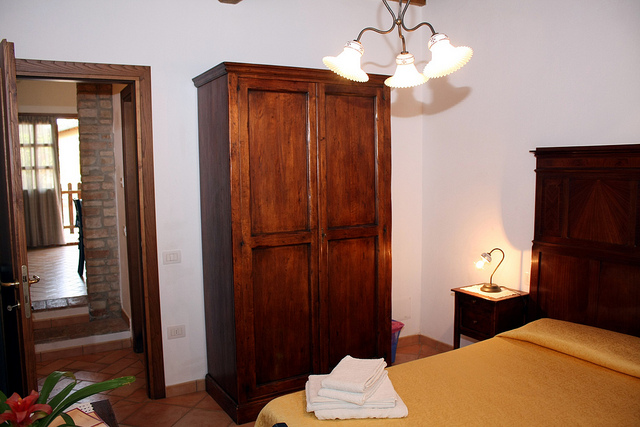<image>What furniture is between the two lamps? I am not sure what furniture is between the two lamps. It could be a bed, a nightstand, or nothing. What furniture is between the two lamps? I don't know what furniture is between the two lamps in the image. It can be either a bed or a nightstand. 